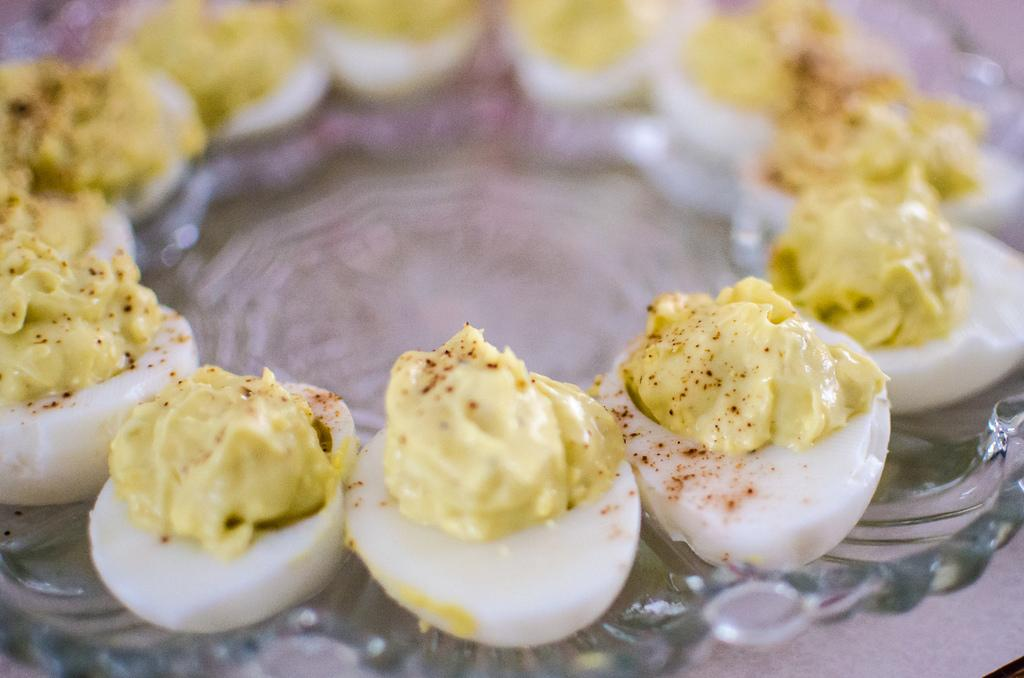What object is visible on the glass plate in the image? Boiled eggs are present on the glass plate in the image. What type of material is the plate made of? The plate is made of glass. How much money is visible on the glass plate in the image? There is no money visible on the glass plate in the image; only boiled eggs are present. 